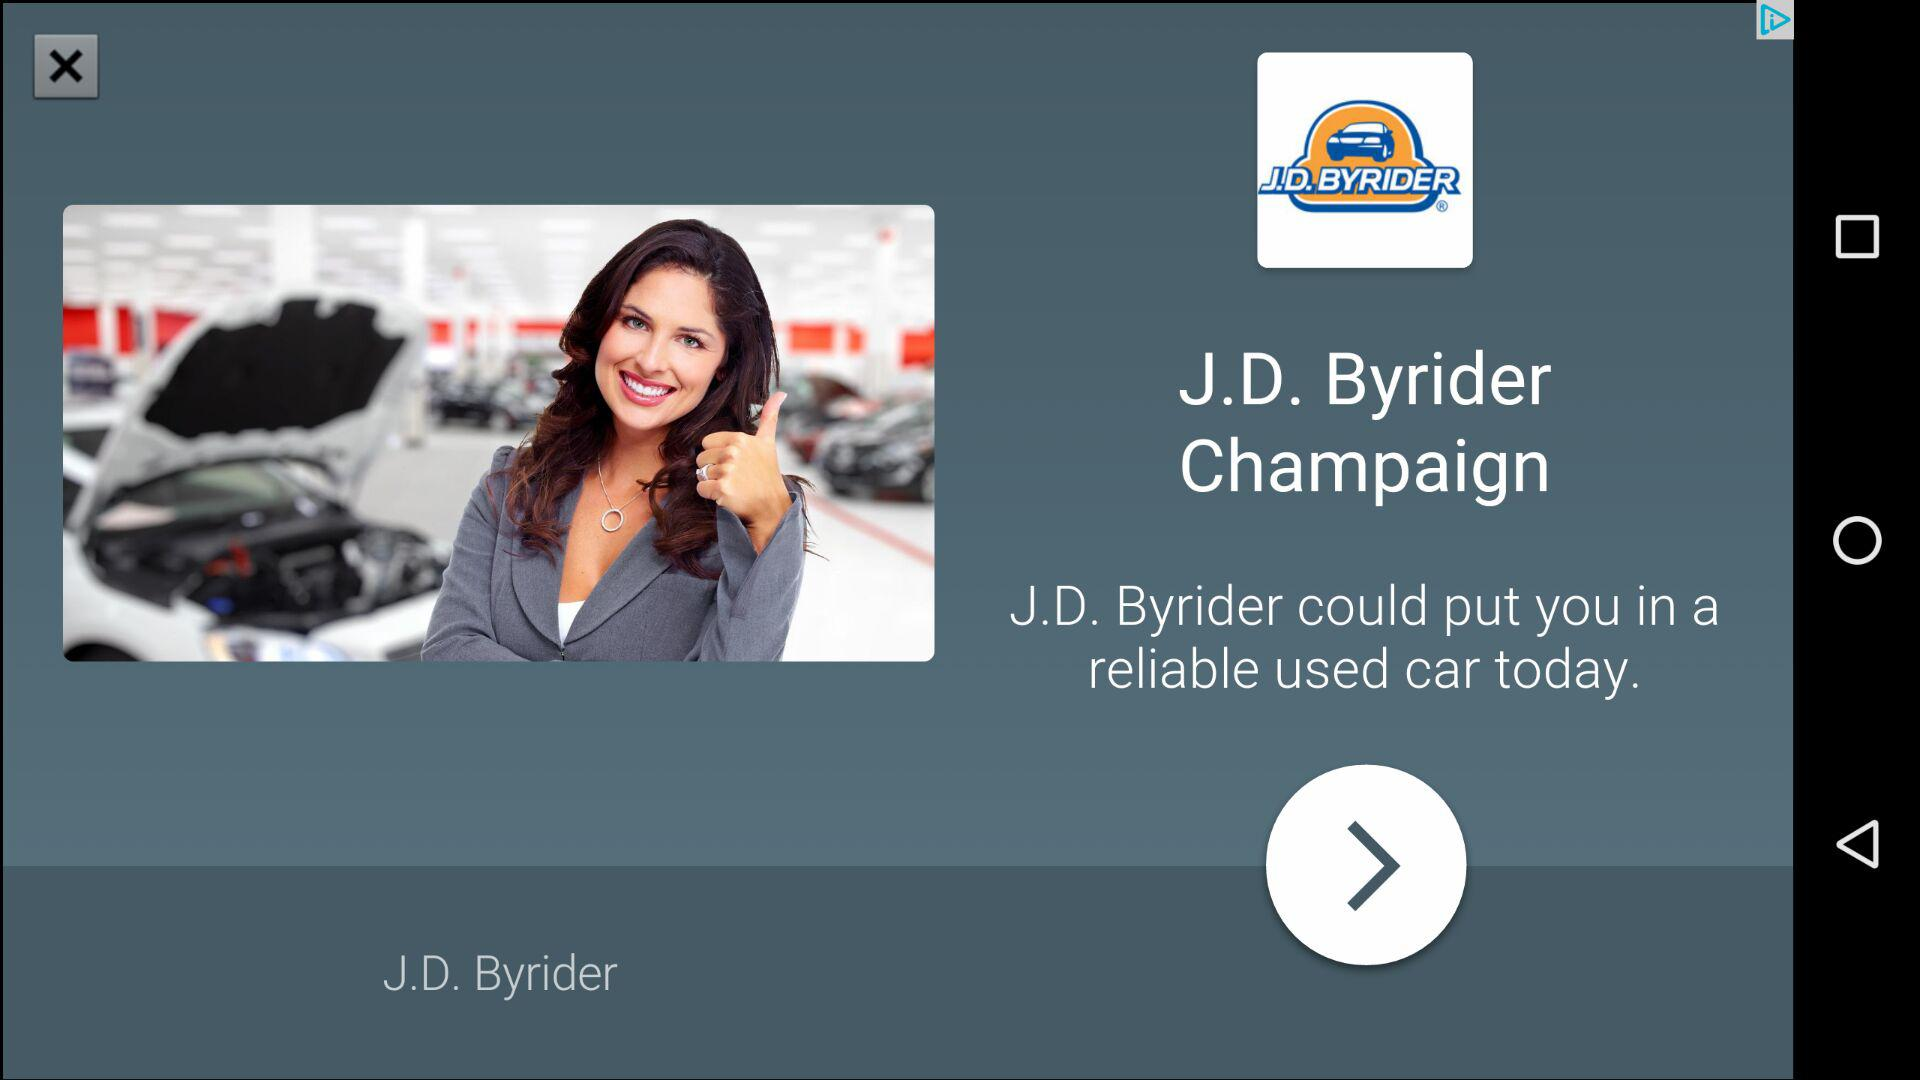What is the company name? The company name is J.D. Byrider. 